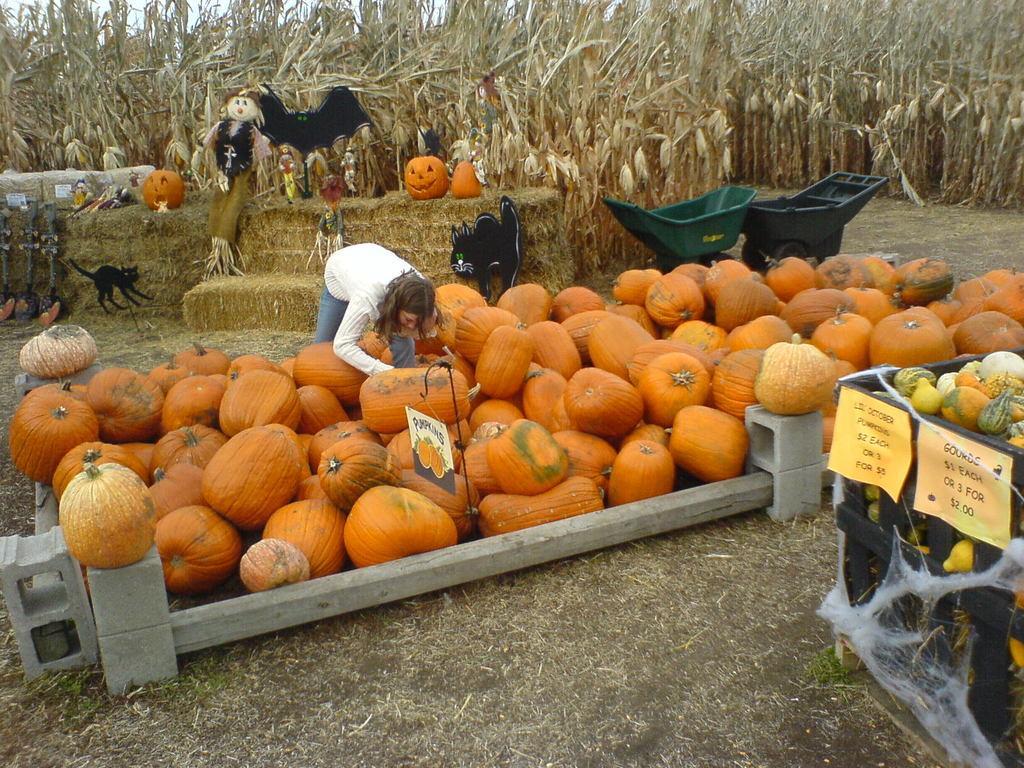Could you give a brief overview of what you see in this image? In this image we can see some pumpkins on the ground and some other fruits in a box, we can see few carts, plants and some other objects. 